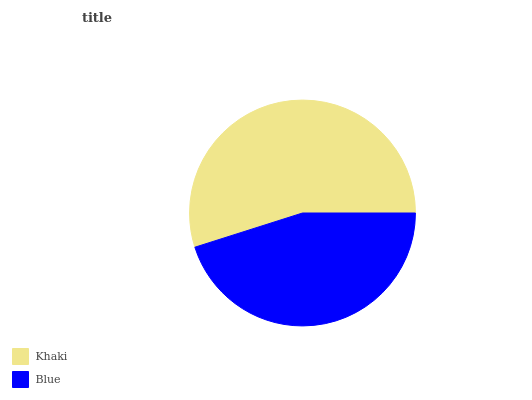Is Blue the minimum?
Answer yes or no. Yes. Is Khaki the maximum?
Answer yes or no. Yes. Is Blue the maximum?
Answer yes or no. No. Is Khaki greater than Blue?
Answer yes or no. Yes. Is Blue less than Khaki?
Answer yes or no. Yes. Is Blue greater than Khaki?
Answer yes or no. No. Is Khaki less than Blue?
Answer yes or no. No. Is Khaki the high median?
Answer yes or no. Yes. Is Blue the low median?
Answer yes or no. Yes. Is Blue the high median?
Answer yes or no. No. Is Khaki the low median?
Answer yes or no. No. 